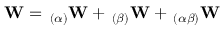<formula> <loc_0><loc_0><loc_500><loc_500>W = \, _ { ( \alpha ) } W + \, _ { ( \beta ) } W + \, _ { ( \alpha \beta ) } W</formula> 